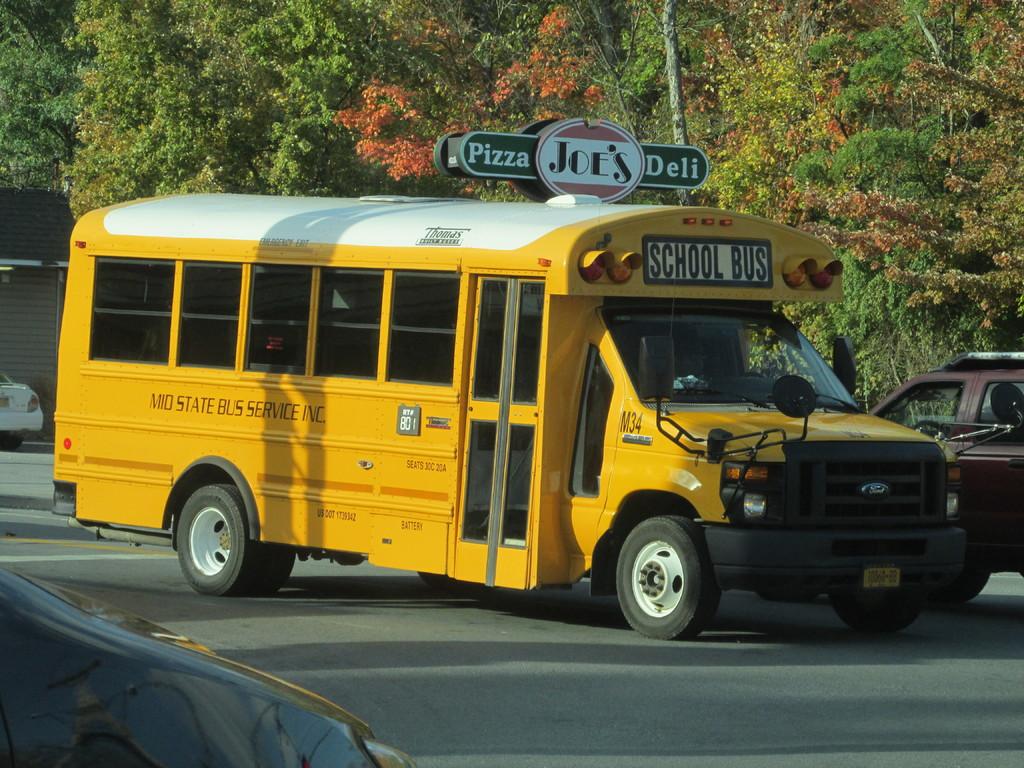What deli is shown?
Your answer should be very brief. Joe's. 